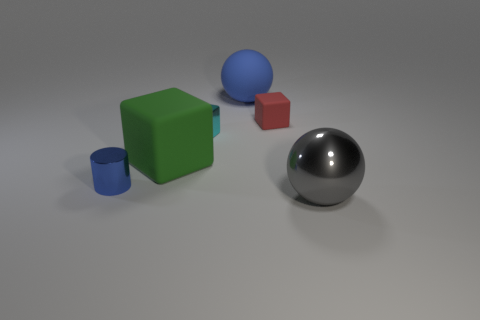There is another green thing that is the same shape as the tiny matte object; what is its material?
Provide a short and direct response. Rubber. What number of things are either big things that are to the right of the cyan block or metal objects?
Your response must be concise. 4. There is a blue object that is the same material as the large gray sphere; what is its shape?
Offer a very short reply. Cylinder. How many big gray metallic things have the same shape as the tiny rubber object?
Give a very brief answer. 0. What is the material of the small red object?
Make the answer very short. Rubber. Do the matte sphere and the tiny thing in front of the tiny cyan shiny thing have the same color?
Keep it short and to the point. Yes. What number of balls are large matte things or small blue metal things?
Provide a succinct answer. 1. The tiny metallic thing that is left of the large green thing is what color?
Offer a very short reply. Blue. The large rubber object that is the same color as the cylinder is what shape?
Provide a short and direct response. Sphere. How many green blocks have the same size as the matte ball?
Give a very brief answer. 1. 